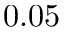<formula> <loc_0><loc_0><loc_500><loc_500>0 . 0 5</formula> 